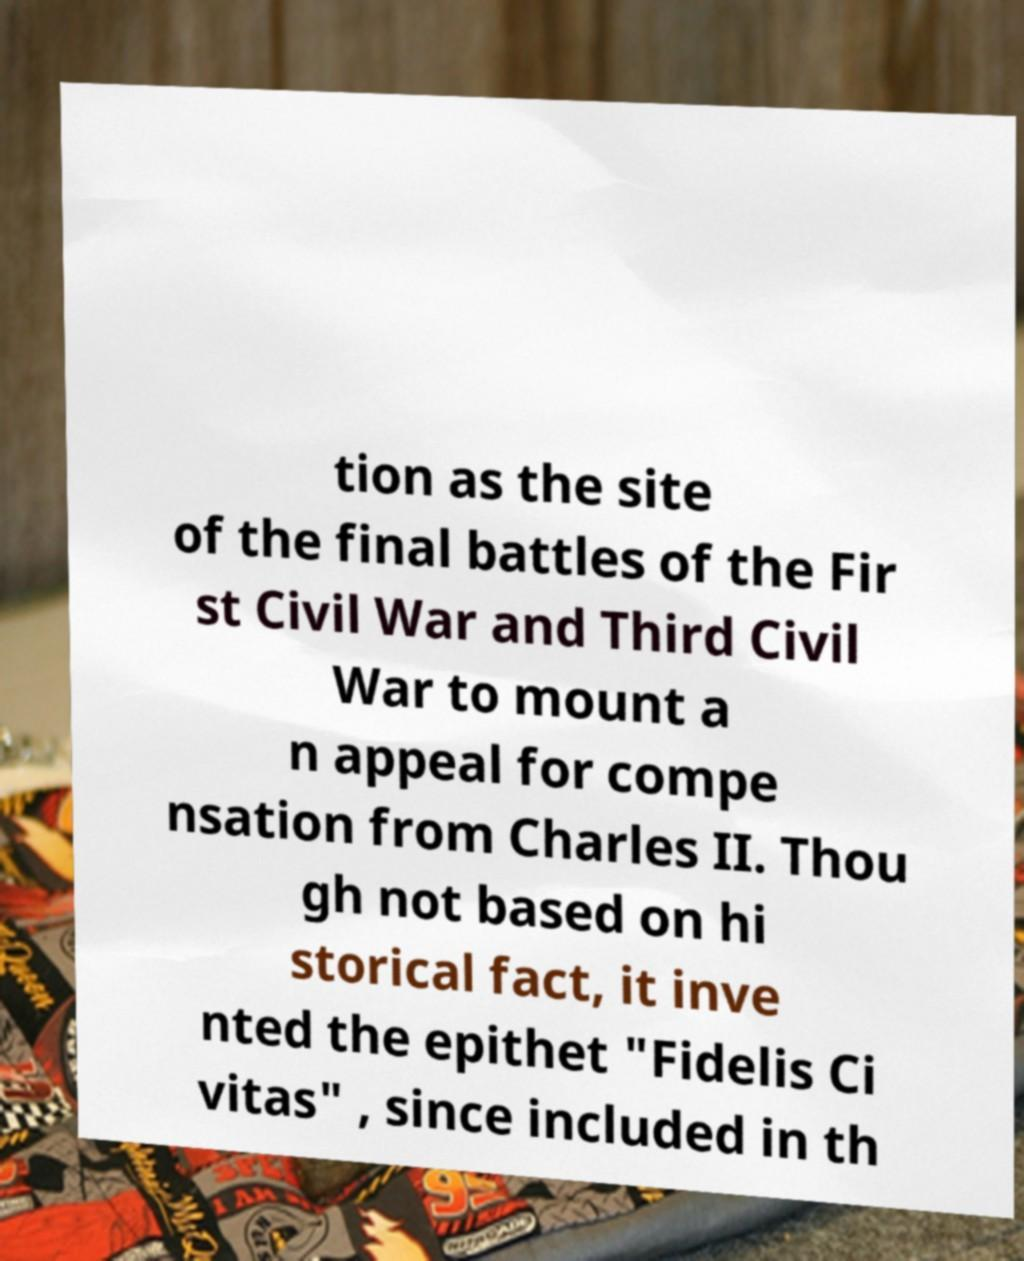What messages or text are displayed in this image? I need them in a readable, typed format. tion as the site of the final battles of the Fir st Civil War and Third Civil War to mount a n appeal for compe nsation from Charles II. Thou gh not based on hi storical fact, it inve nted the epithet "Fidelis Ci vitas" , since included in th 